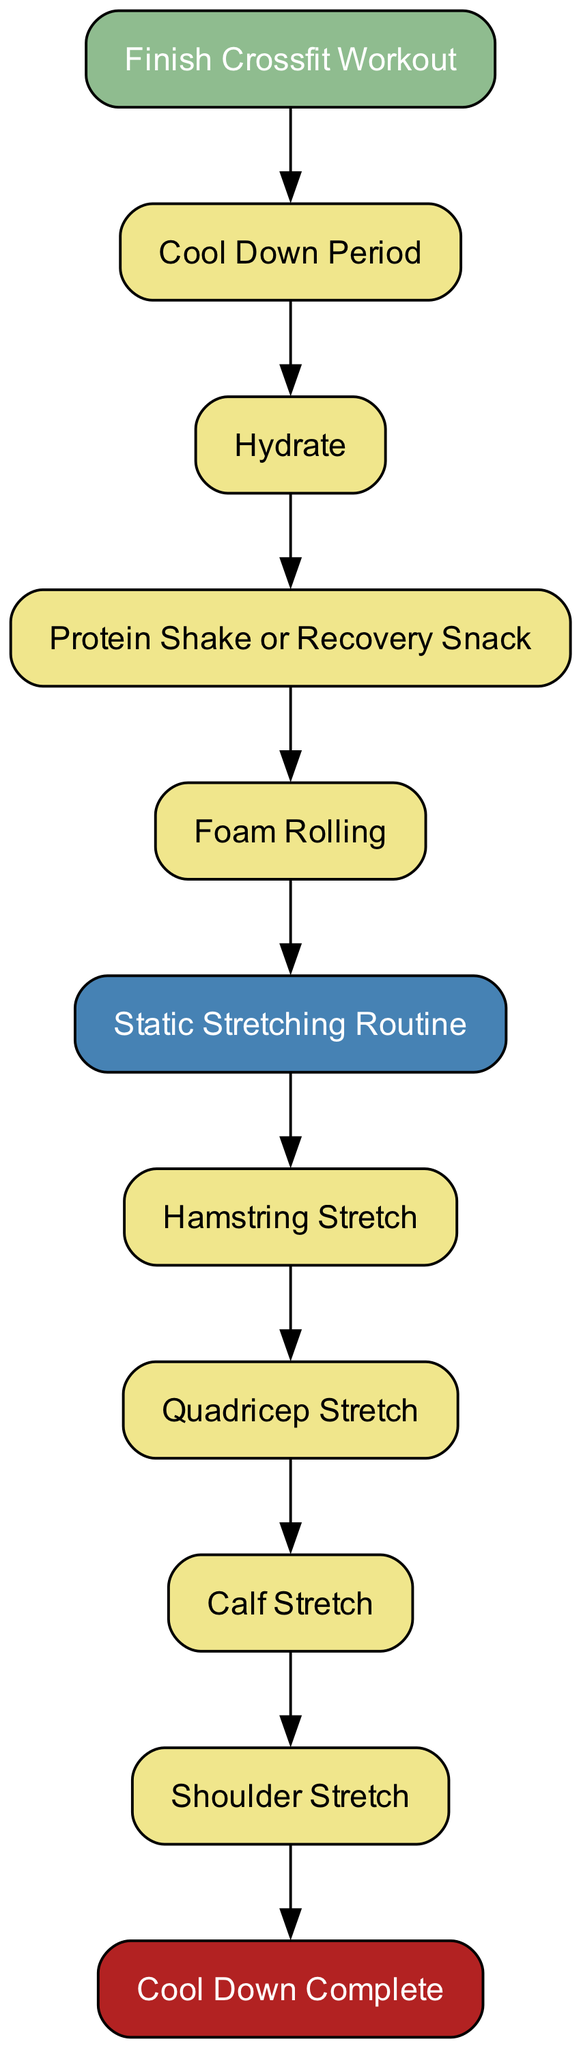What is the first action after finishing the Crossfit workout? The diagram indicates that the first action taken after "Finish Crossfit Workout" is "Cool Down Period." This is directly shown as the first edge leading from the start node to the action node.
Answer: Cool Down Period How many distinct stretching routines are mentioned in the diagram? By counting the individual static stretching actions within the nodes, we find "Hamstring Stretch," "Quadricep Stretch," "Calf Stretch," and "Shoulder Stretch," totaling four distinct stretches.
Answer: 4 What action follows after foam rolling? The action that comes right after "Foam Rolling" according to the flow of the diagram is "Static Stretching Routine." This is connected by a direct edge from "Foam Rolling" to "Static Stretching Routine."
Answer: Static Stretching Routine What type of action is "Protein Shake or Recovery Snack"? The type of action indicated by the node "Protein Shake or Recovery Snack" is an "action" type, as shown in the diagram categorization of nodes. Each node specifies its type, and this one is defined as an action.
Answer: action What is the last action before the cool down is complete? The diagram shows that the last action before reaching "Cool Down Complete" is "Shoulder Stretch." This is evident as the final action before the end node in the flow of the diagram.
Answer: Shoulder Stretch What is the total number of edges present in the diagram? To determine the total number of edges, we can count all connections in the diagram. There are ten edges listed connecting various action nodes and transitions, indicating the flow of activities in the post-workout recovery routine.
Answer: 10 Which action comes after hydration? Following the "Hydrate" action in the diagram, the next step is "Protein Shake or Recovery Snack." This is shown by a direct edge flowing from "Hydrate" to "Protein Shake or Recovery Snack."
Answer: Protein Shake or Recovery Snack What color represents the static stretching routines in the diagram? The static stretching routines are represented by the color blue, specifically with the fill color designated as "#4682B4" for the relevant nodes in the diagram.
Answer: blue 